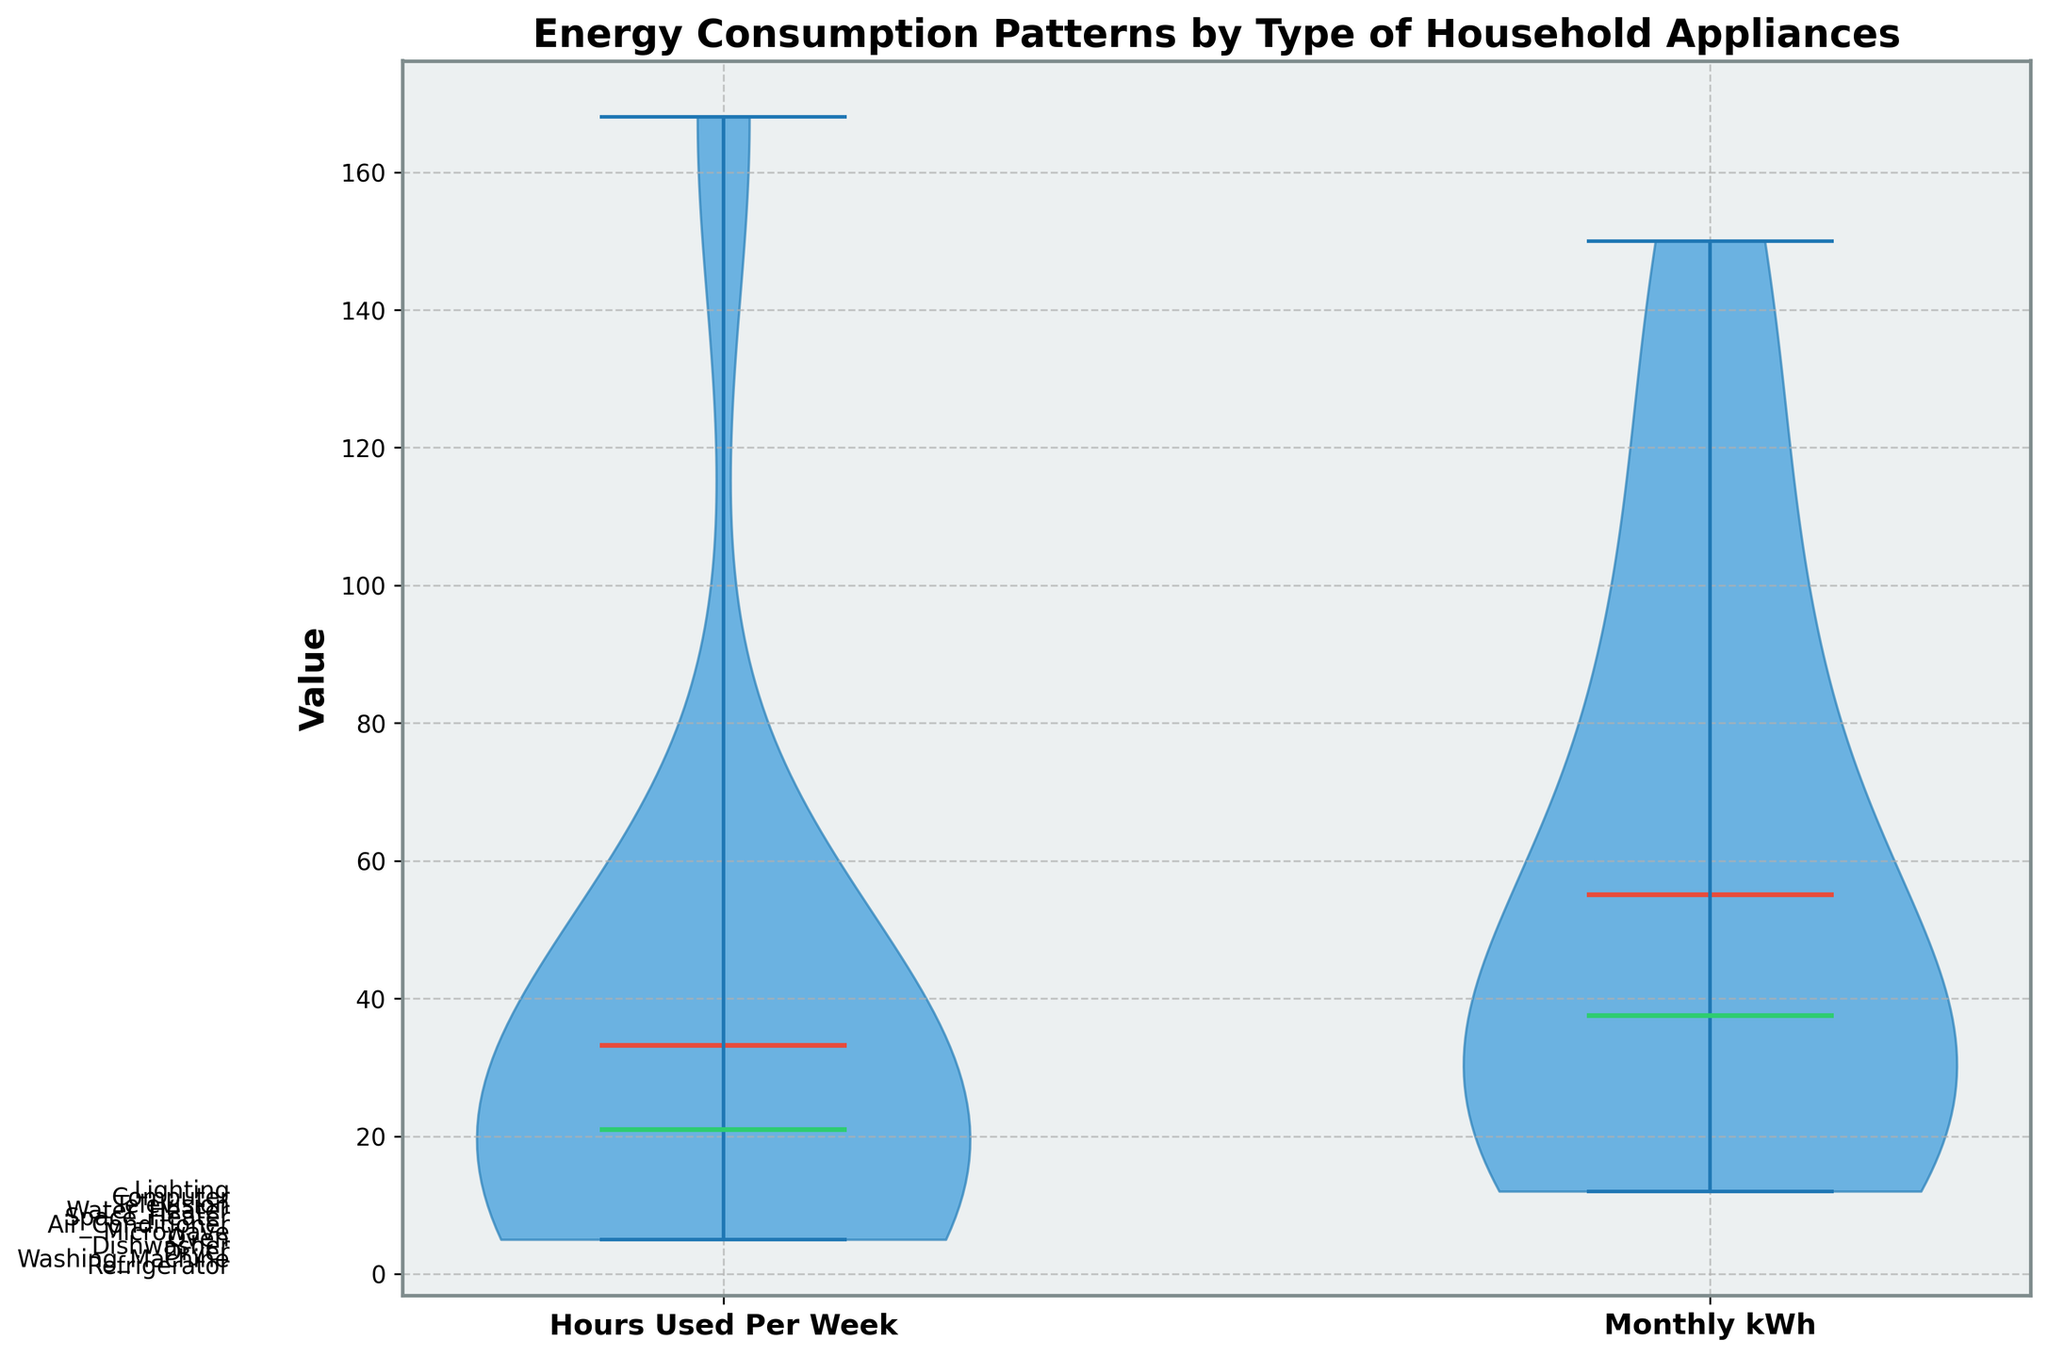What is the title of the figure? The title of the figure is usually placed at the top and summarized in a bold font. It indicates the overall theme or subject of the data presented. In this case, it is written clearly at the top of the plot.
Answer: Energy Consumption Patterns by Type of Household Appliances What are the labels on the x-axis? The labels on the x-axis are provided directly beneath the ticks for easy identification. In this figure, they are written in a bold font and enlarged for clarity.
Answer: Hours Used Per Week, Monthly kWh How many appliances are being compared in the figure? Count the individual appliance names listed along the y-axis or within the plot. Each name corresponds to a different appliance.
Answer: 12 Which color represents the mean value in the violin plots? The mean value is typically represented using a distinctive color to differentiate it from other lines. In this figure, the mean values are marked with a specific color that stands out from the background and other elements.
Answer: Red Which has a higher median value, Hours Used Per Week or Monthly kWh? To find this, compare the positions of the median lines for both categories in the violin plots. The median is usually indicated by a different color or thickness.
Answer: Monthly kWh What is the median value of Hours Used Per Week? Locate the median line within the violin plot for Hours Used Per Week. It is distinctively colored for easy identification. Estimate its value based on the y-axis.
Answer: Approximately 28 Which appliance is used the most in terms of hours per week? Look at the extent of the Hours Used Per Week violin plot. The appliance associated with the widest plot in this category likely has the highest hours usage.
Answer: Refrigerator Is the mean value of Monthly kWh greater than the mean value of Hours Used Per Week? Compare the mean lines (colored red) in both violin plots. The mean values can be visually compared by their relative positions.
Answer: Yes What is the overall trend you see in appliance energy consumption? By analyzing the spread and distribution in both violin plots, one can observe how energy usage varies among appliances. Pay attention to the width and height of the plots as well as the central tendency indicators.
Answer: Air conditioners and water heaters consume the most energy Which appliance has a smaller spread in Monthly kWh usage, Refrigerator or Space Heater? Observe the width of the violin plots for both Refrigerator and Space Heater in the Monthly kWh category. A narrower plot indicates less variation in the data.
Answer: Refrigerator 